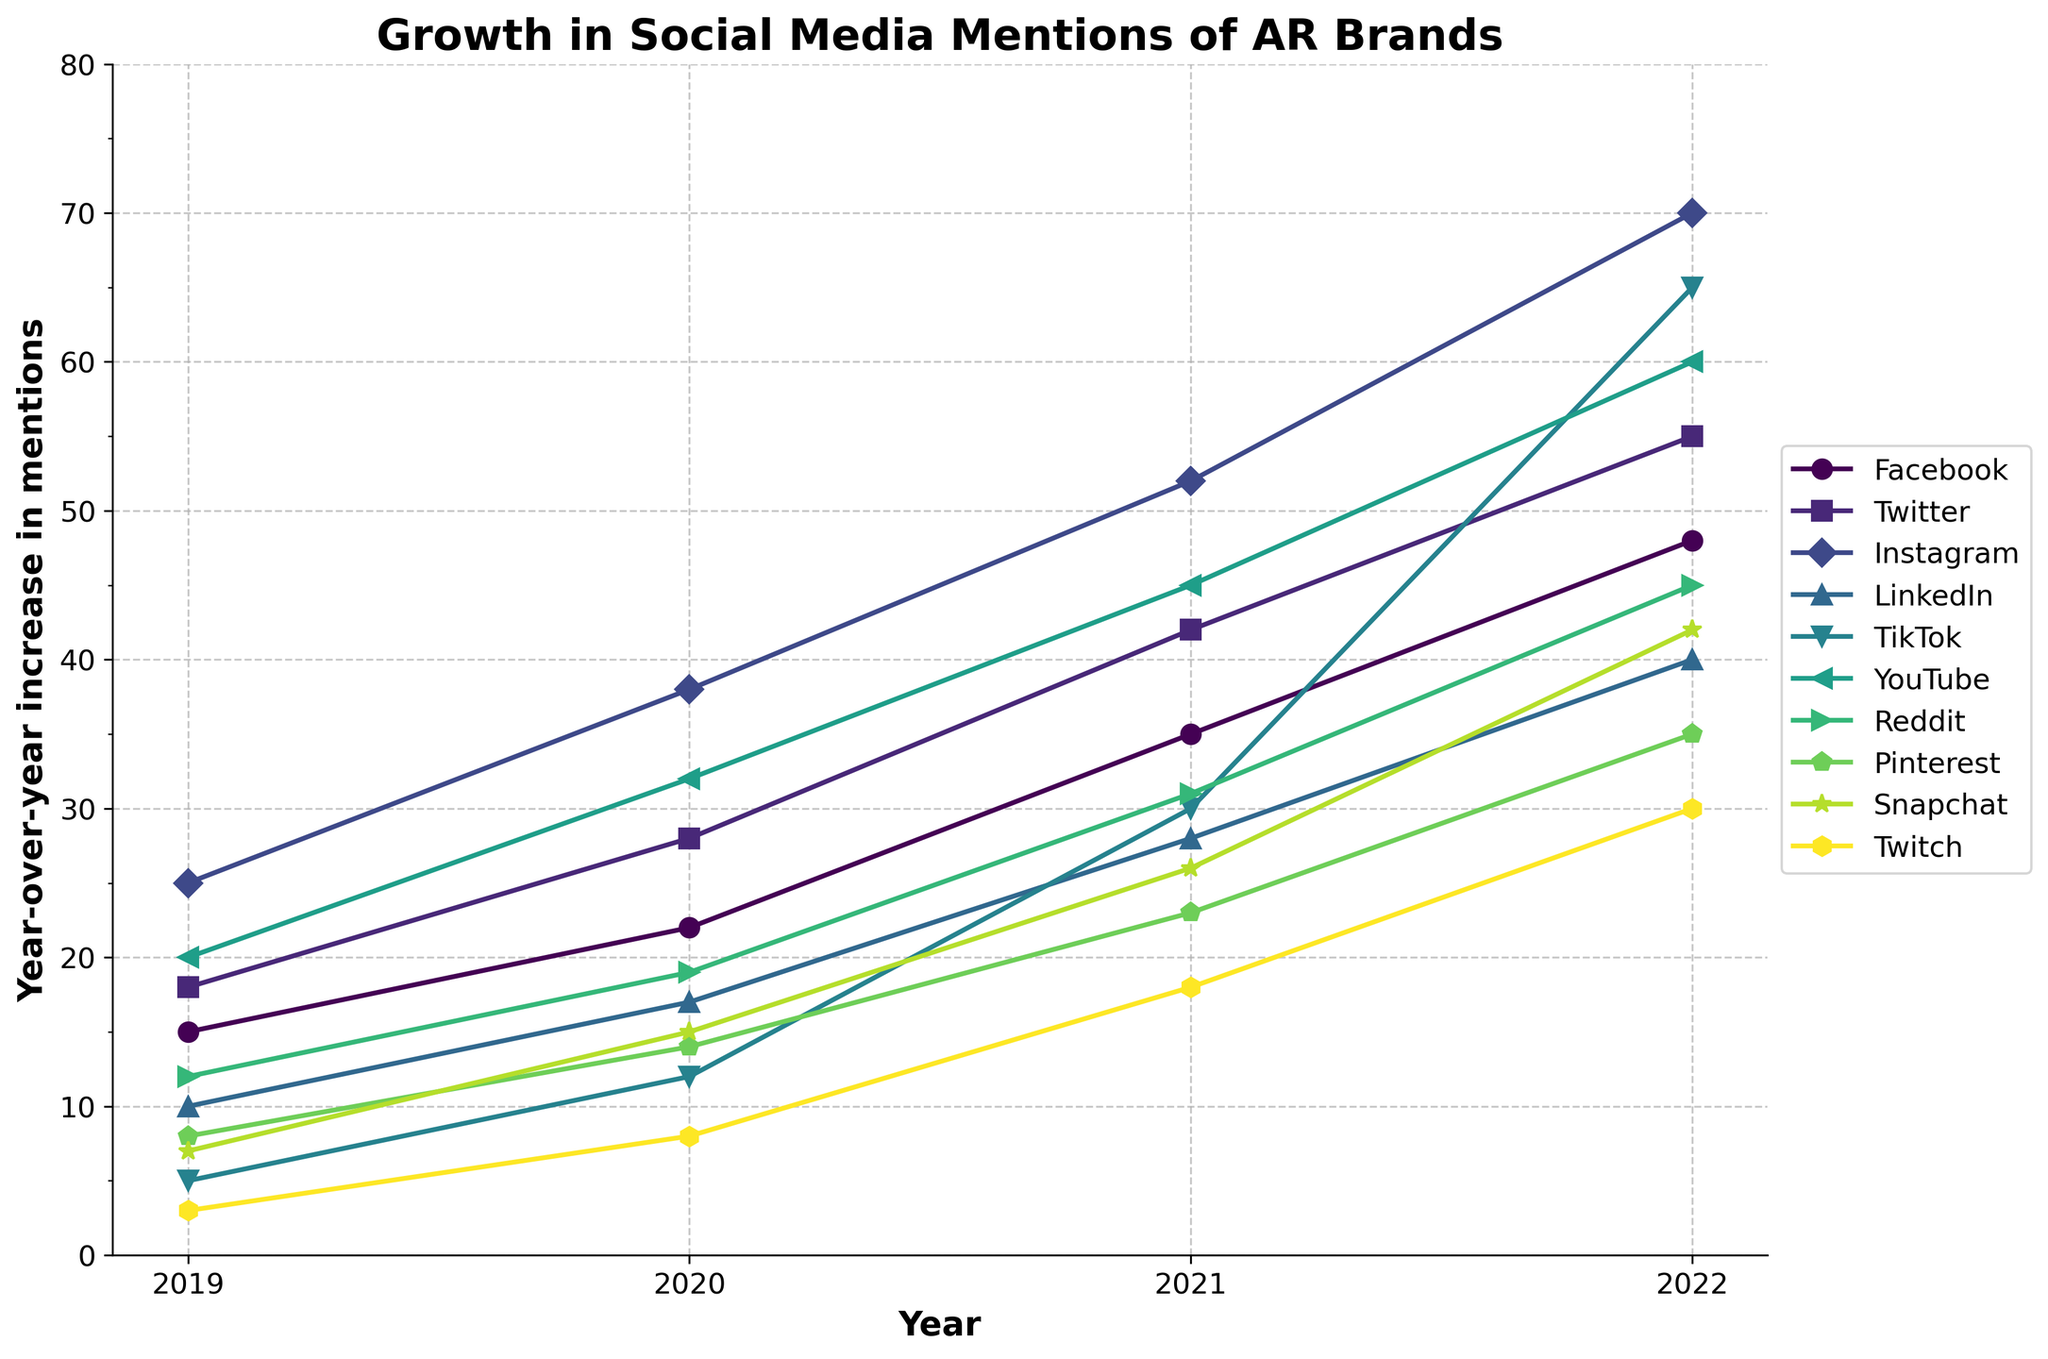Which platform showed the greatest increase in social media mentions between 2019 and 2022? To find which platform had the greatest increase, look at each platform's mentions in 2019 and compare them to their mentions in 2022. The largest difference represents the greatest increase.
Answer: TikTok Which platform had the least increase in mentions from 2019 to 2022? Compare the increase in mentions for each platform from 2019 to 2022. The smallest difference indicates the least increase.
Answer: Twitch What is the combined increase in social media mentions for Instagram and Facebook from 2019 to 2022? Find the individual increases for Instagram (70 - 25 = 45 mentions) and Facebook (48 - 15 = 33 mentions), then sum these values (45 + 33).
Answer: 78 Which year saw the largest average increase in mentions across all platforms? Find the annual increase for each platform across all years, then calculate the average increase for each year and compare them. The year with the highest average increase is the answer.
Answer: 2022 How does the increase in mentions for LinkedIn between 2019 and 2022 compare to Reddit's increase over the same period? Calculate the increase for LinkedIn (40 - 10 = 30 mentions) and for Reddit (45 - 12 = 33 mentions). Then compare these increases.
Answer: LinkedIn's increase is 3 mentions less than Reddit's Which year had the smallest increase in Pinterest mentions compared to the previous year? Calculate the year-over-year increase for Pinterest mentions: (14 - 8) for 2020, (23 - 14) for 2021, and (35 - 23) for 2022. The smallest increase is the answer.
Answer: 2021 Which platform's mentions grew faster than Twitter's but slower than Instagram's from 2019 to 2022? Calculate the increase for Twitter (55 - 18 = 37 mentions) and Instagram (70 - 25 = 45 mentions). Identify the platform with an increase between 37 and 45 mentions.
Answer: YouTube Of Facebook, Instagram, and Twitter, which saw the largest increase in mentions from 2019 to 2022? Calculate the increase for Facebook (48 - 15 = 33 mentions), Instagram (70 - 25 = 45 mentions), and Twitter (55 - 18 = 37 mentions). Compare these values.
Answer: Instagram What is the percentage increase in mentions for TikTok from 2021 to 2022? Calculate the increase from 2021 to 2022 for TikTok (65 - 30 = 35 mentions). Then calculate the percentage increase (35 / 30) * 100.
Answer: 116.67% How many platforms saw more than a 20-mention increase in social media mentions from 2020 to 2021? Calculate the increase for each platform from 2020 to 2021 and count how many had an increase greater than 20 mentions.
Answer: 4 platforms (Instagram, TikTok, YouTube, and Reddit) 